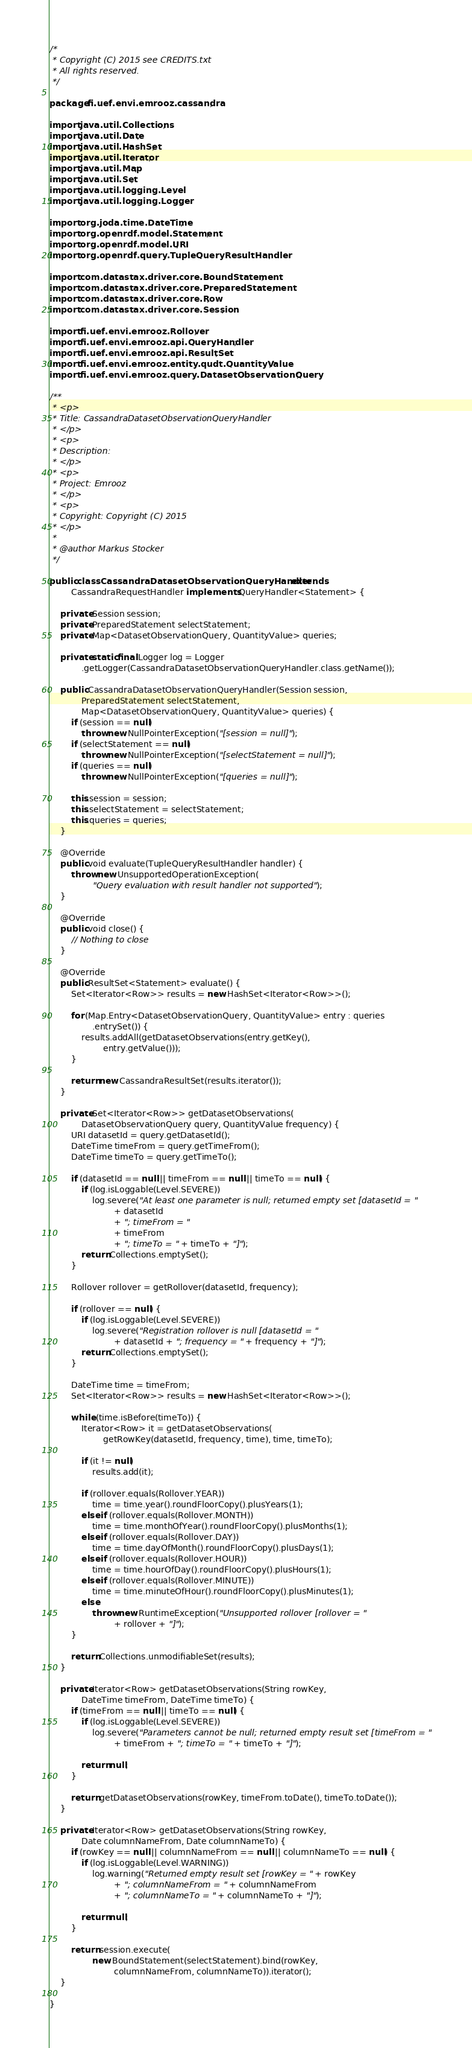Convert code to text. <code><loc_0><loc_0><loc_500><loc_500><_Java_>/*
 * Copyright (C) 2015 see CREDITS.txt
 * All rights reserved.
 */

package fi.uef.envi.emrooz.cassandra;

import java.util.Collections;
import java.util.Date;
import java.util.HashSet;
import java.util.Iterator;
import java.util.Map;
import java.util.Set;
import java.util.logging.Level;
import java.util.logging.Logger;

import org.joda.time.DateTime;
import org.openrdf.model.Statement;
import org.openrdf.model.URI;
import org.openrdf.query.TupleQueryResultHandler;

import com.datastax.driver.core.BoundStatement;
import com.datastax.driver.core.PreparedStatement;
import com.datastax.driver.core.Row;
import com.datastax.driver.core.Session;

import fi.uef.envi.emrooz.Rollover;
import fi.uef.envi.emrooz.api.QueryHandler;
import fi.uef.envi.emrooz.api.ResultSet;
import fi.uef.envi.emrooz.entity.qudt.QuantityValue;
import fi.uef.envi.emrooz.query.DatasetObservationQuery;

/**
 * <p>
 * Title: CassandraDatasetObservationQueryHandler
 * </p>
 * <p>
 * Description:
 * </p>
 * <p>
 * Project: Emrooz
 * </p>
 * <p>
 * Copyright: Copyright (C) 2015
 * </p>
 * 
 * @author Markus Stocker
 */

public class CassandraDatasetObservationQueryHandler extends
		CassandraRequestHandler implements QueryHandler<Statement> {

	private Session session;
	private PreparedStatement selectStatement;
	private Map<DatasetObservationQuery, QuantityValue> queries;

	private static final Logger log = Logger
			.getLogger(CassandraDatasetObservationQueryHandler.class.getName());

	public CassandraDatasetObservationQueryHandler(Session session,
			PreparedStatement selectStatement,
			Map<DatasetObservationQuery, QuantityValue> queries) {
		if (session == null)
			throw new NullPointerException("[session = null]");
		if (selectStatement == null)
			throw new NullPointerException("[selectStatement = null]");
		if (queries == null)
			throw new NullPointerException("[queries = null]");

		this.session = session;
		this.selectStatement = selectStatement;
		this.queries = queries;
	}

	@Override
	public void evaluate(TupleQueryResultHandler handler) {
		throw new UnsupportedOperationException(
				"Query evaluation with result handler not supported");
	}

	@Override
	public void close() {
		// Nothing to close
	}

	@Override
	public ResultSet<Statement> evaluate() {
		Set<Iterator<Row>> results = new HashSet<Iterator<Row>>();

		for (Map.Entry<DatasetObservationQuery, QuantityValue> entry : queries
				.entrySet()) {
			results.addAll(getDatasetObservations(entry.getKey(),
					entry.getValue()));
		}

		return new CassandraResultSet(results.iterator());
	}

	private Set<Iterator<Row>> getDatasetObservations(
			DatasetObservationQuery query, QuantityValue frequency) {
		URI datasetId = query.getDatasetId();
		DateTime timeFrom = query.getTimeFrom();
		DateTime timeTo = query.getTimeTo();

		if (datasetId == null || timeFrom == null || timeTo == null) {
			if (log.isLoggable(Level.SEVERE))
				log.severe("At least one parameter is null; returned empty set [datasetId = "
						+ datasetId
						+ "; timeFrom = "
						+ timeFrom
						+ "; timeTo = " + timeTo + "]");
			return Collections.emptySet();
		}

		Rollover rollover = getRollover(datasetId, frequency);

		if (rollover == null) {
			if (log.isLoggable(Level.SEVERE))
				log.severe("Registration rollover is null [datasetId = "
						+ datasetId + "; frequency = " + frequency + "]");
			return Collections.emptySet();
		}

		DateTime time = timeFrom;
		Set<Iterator<Row>> results = new HashSet<Iterator<Row>>();

		while (time.isBefore(timeTo)) {
			Iterator<Row> it = getDatasetObservations(
					getRowKey(datasetId, frequency, time), time, timeTo);

			if (it != null)
				results.add(it);

			if (rollover.equals(Rollover.YEAR))
				time = time.year().roundFloorCopy().plusYears(1);
			else if (rollover.equals(Rollover.MONTH))
				time = time.monthOfYear().roundFloorCopy().plusMonths(1);
			else if (rollover.equals(Rollover.DAY))
				time = time.dayOfMonth().roundFloorCopy().plusDays(1);
			else if (rollover.equals(Rollover.HOUR))
				time = time.hourOfDay().roundFloorCopy().plusHours(1);
			else if (rollover.equals(Rollover.MINUTE))
				time = time.minuteOfHour().roundFloorCopy().plusMinutes(1);
			else
				throw new RuntimeException("Unsupported rollover [rollover = "
						+ rollover + "]");
		}

		return Collections.unmodifiableSet(results);
	}

	private Iterator<Row> getDatasetObservations(String rowKey,
			DateTime timeFrom, DateTime timeTo) {
		if (timeFrom == null || timeTo == null) {
			if (log.isLoggable(Level.SEVERE))
				log.severe("Parameters cannot be null; returned empty result set [timeFrom = "
						+ timeFrom + "; timeTo = " + timeTo + "]");

			return null;
		}

		return getDatasetObservations(rowKey, timeFrom.toDate(), timeTo.toDate());
	}

	private Iterator<Row> getDatasetObservations(String rowKey,
			Date columnNameFrom, Date columnNameTo) {
		if (rowKey == null || columnNameFrom == null || columnNameTo == null) {
			if (log.isLoggable(Level.WARNING))
				log.warning("Returned empty result set [rowKey = " + rowKey
						+ "; columnNameFrom = " + columnNameFrom
						+ "; columnNameTo = " + columnNameTo + "]");

			return null;
		}

		return session.execute(
				new BoundStatement(selectStatement).bind(rowKey,
						columnNameFrom, columnNameTo)).iterator();
	}

}
</code> 